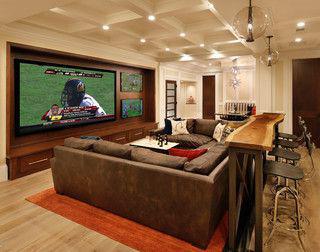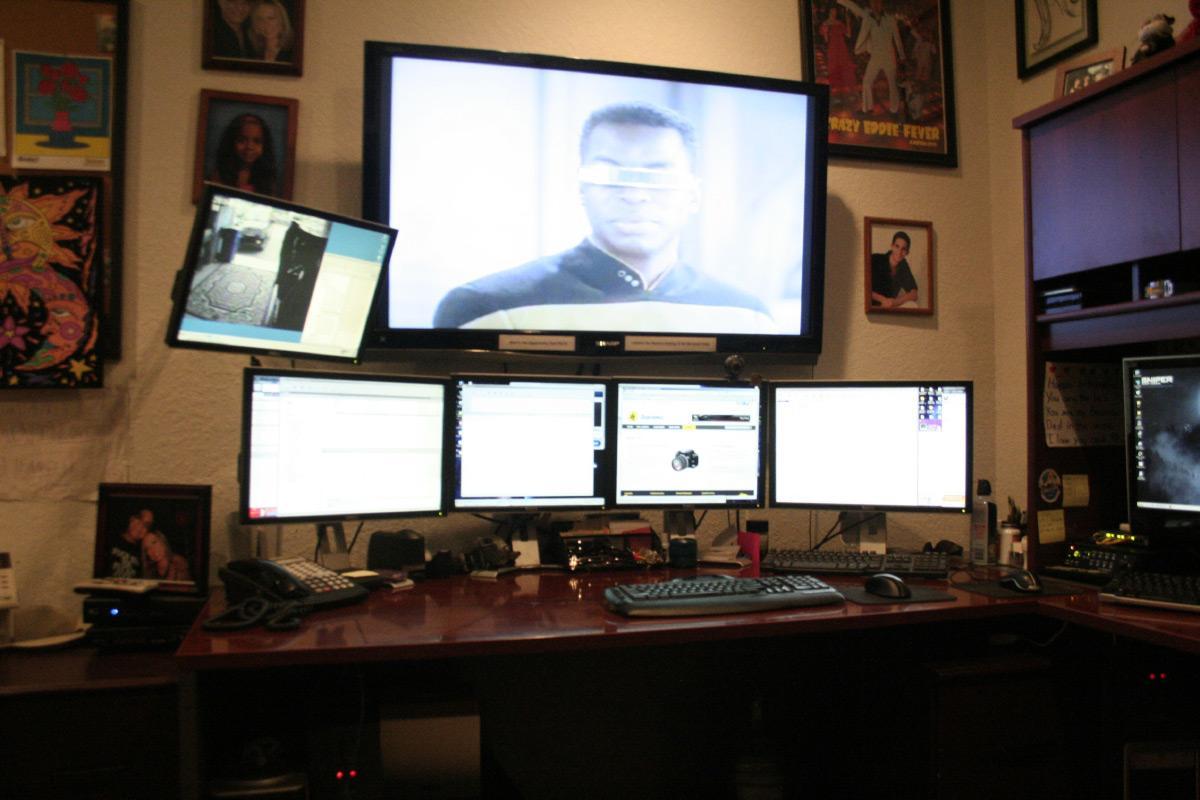The first image is the image on the left, the second image is the image on the right. For the images displayed, is the sentence "there are lights haging over the bar" factually correct? Answer yes or no. Yes. The first image is the image on the left, the second image is the image on the right. Analyze the images presented: Is the assertion "None of the screens show a basketball game." valid? Answer yes or no. Yes. 